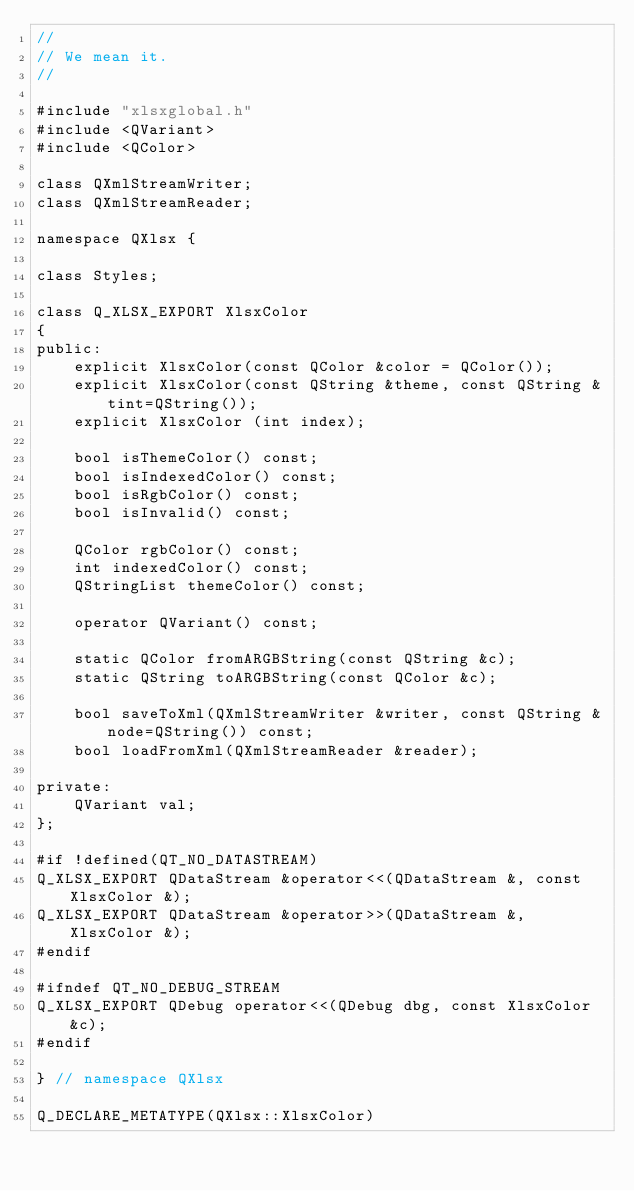<code> <loc_0><loc_0><loc_500><loc_500><_C_>//
// We mean it.
//

#include "xlsxglobal.h"
#include <QVariant>
#include <QColor>

class QXmlStreamWriter;
class QXmlStreamReader;

namespace QXlsx {

class Styles;

class Q_XLSX_EXPORT XlsxColor
{
public:
    explicit XlsxColor(const QColor &color = QColor());
    explicit XlsxColor(const QString &theme, const QString &tint=QString());
    explicit XlsxColor (int index);

    bool isThemeColor() const;
    bool isIndexedColor() const;
    bool isRgbColor() const;
    bool isInvalid() const;

    QColor rgbColor() const;
    int indexedColor() const;
    QStringList themeColor() const;

    operator QVariant() const;

    static QColor fromARGBString(const QString &c);
    static QString toARGBString(const QColor &c);

    bool saveToXml(QXmlStreamWriter &writer, const QString &node=QString()) const;
    bool loadFromXml(QXmlStreamReader &reader);

private:
    QVariant val;
};

#if !defined(QT_NO_DATASTREAM)
Q_XLSX_EXPORT QDataStream &operator<<(QDataStream &, const XlsxColor &);
Q_XLSX_EXPORT QDataStream &operator>>(QDataStream &, XlsxColor &);
#endif

#ifndef QT_NO_DEBUG_STREAM
Q_XLSX_EXPORT QDebug operator<<(QDebug dbg, const XlsxColor &c);
#endif

} // namespace QXlsx

Q_DECLARE_METATYPE(QXlsx::XlsxColor)

</code> 